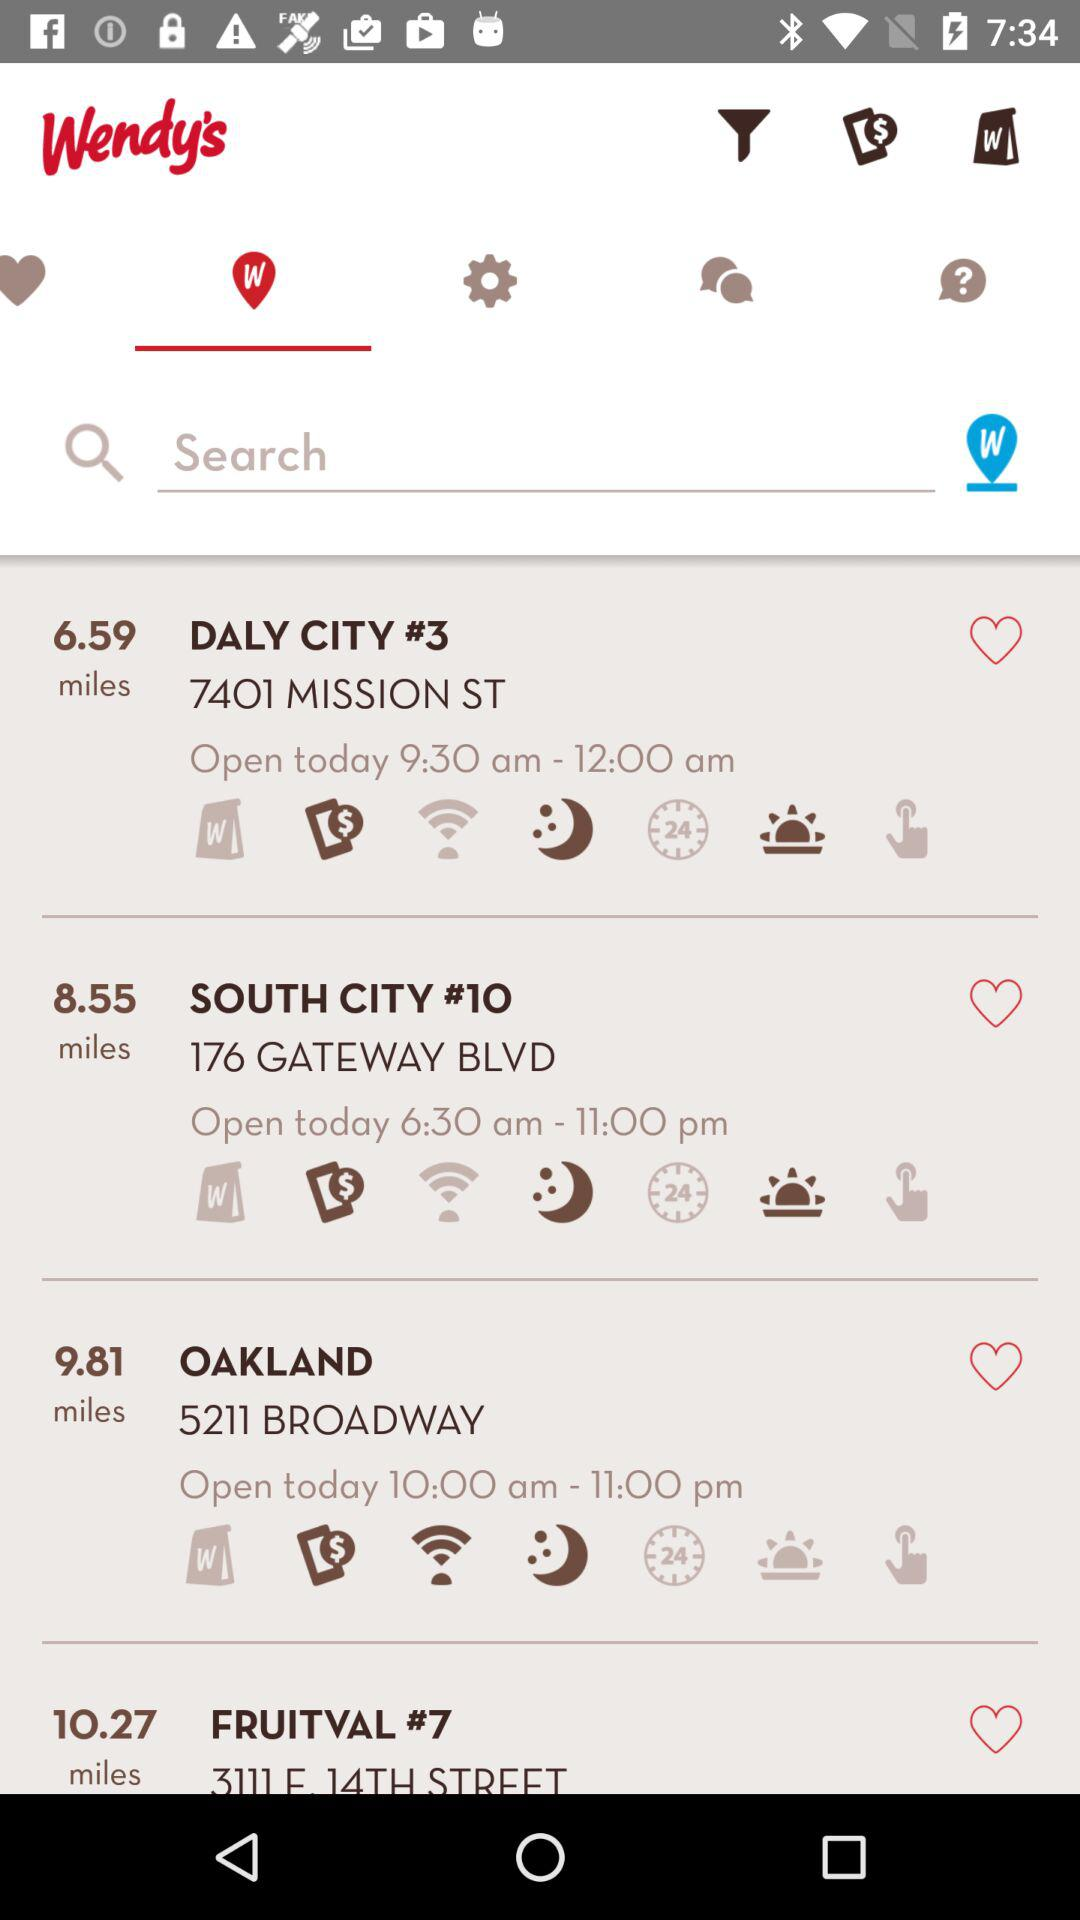How many miles away is Oakland? Oakland is 9.81 miles away. 